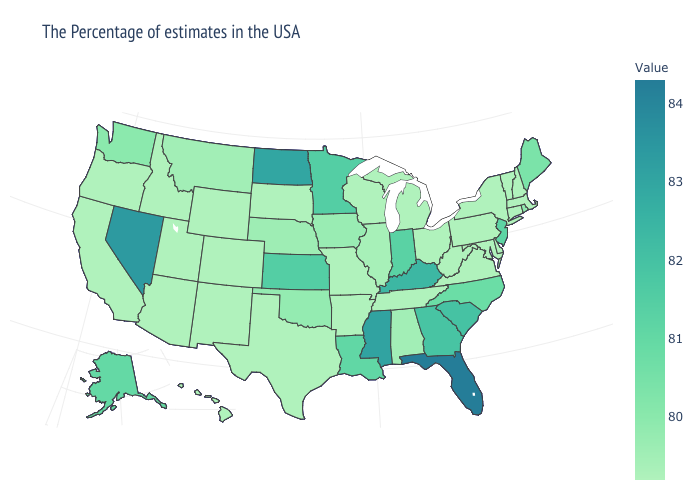Is the legend a continuous bar?
Concise answer only. Yes. Does Connecticut have a lower value than Alaska?
Quick response, please. Yes. Does Louisiana have a lower value than Oklahoma?
Answer briefly. No. Among the states that border West Virginia , which have the lowest value?
Concise answer only. Maryland, Pennsylvania, Virginia, Ohio. 